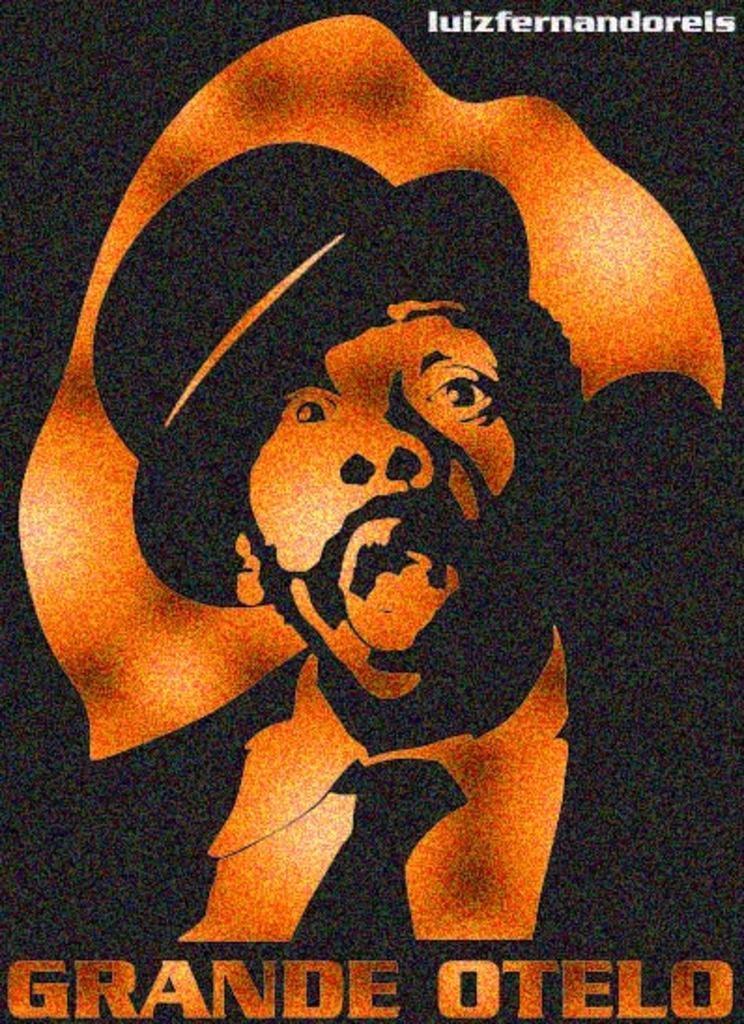How would you summarize this image in a sentence or two? In this picture we can see a poster. In this poster, we can see a person and a watermark. 